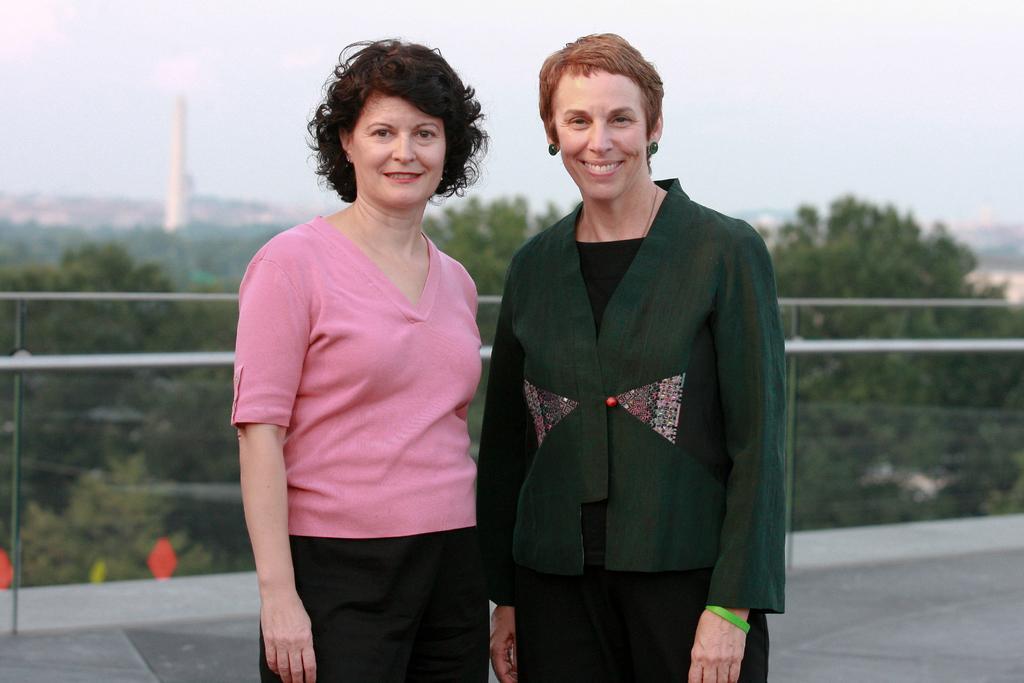Describe this image in one or two sentences. In this picture we can see two women standing and smiling and in the background we can see trees, tower, sky. 